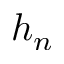<formula> <loc_0><loc_0><loc_500><loc_500>h _ { n }</formula> 